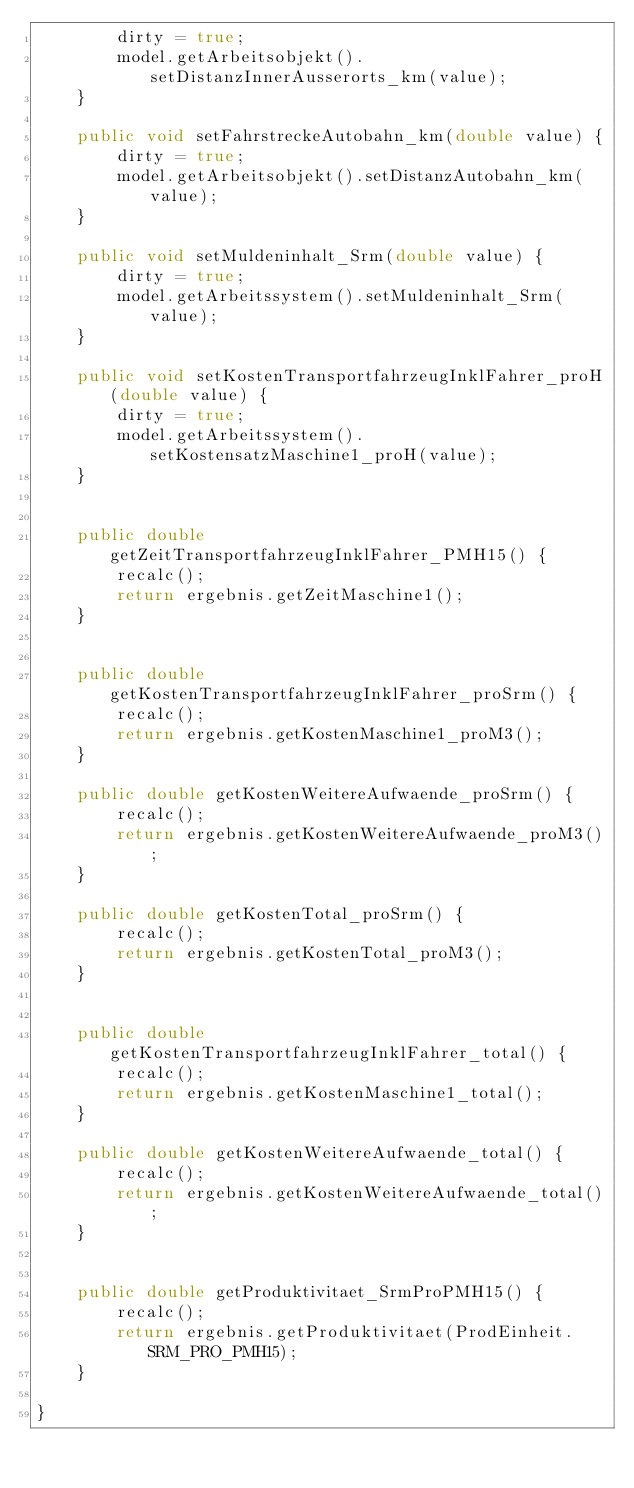Convert code to text. <code><loc_0><loc_0><loc_500><loc_500><_Java_>		dirty = true;
		model.getArbeitsobjekt().setDistanzInnerAusserorts_km(value);
	}
	
	public void setFahrstreckeAutobahn_km(double value) {
		dirty = true;
		model.getArbeitsobjekt().setDistanzAutobahn_km(value);
	}
	
	public void setMuldeninhalt_Srm(double value) {
		dirty = true;
		model.getArbeitssystem().setMuldeninhalt_Srm(value);
	}
	
	public void setKostenTransportfahrzeugInklFahrer_proH(double value) {
		dirty = true;
		model.getArbeitssystem().setKostensatzMaschine1_proH(value);
	}
	
	
	public double getZeitTransportfahrzeugInklFahrer_PMH15() {
		recalc();
		return ergebnis.getZeitMaschine1();
	}
	

	public double getKostenTransportfahrzeugInklFahrer_proSrm() {
		recalc();
		return ergebnis.getKostenMaschine1_proM3();
	}

	public double getKostenWeitereAufwaende_proSrm() {
		recalc();
		return ergebnis.getKostenWeitereAufwaende_proM3();
	}

	public double getKostenTotal_proSrm() {
		recalc();
		return ergebnis.getKostenTotal_proM3();
	}
	

	public double getKostenTransportfahrzeugInklFahrer_total() {
		recalc();
		return ergebnis.getKostenMaschine1_total();
	}

	public double getKostenWeitereAufwaende_total() {
		recalc();
		return ergebnis.getKostenWeitereAufwaende_total();
	}


	public double getProduktivitaet_SrmProPMH15() {
		recalc();
		return ergebnis.getProduktivitaet(ProdEinheit.SRM_PRO_PMH15);
	}

}
</code> 